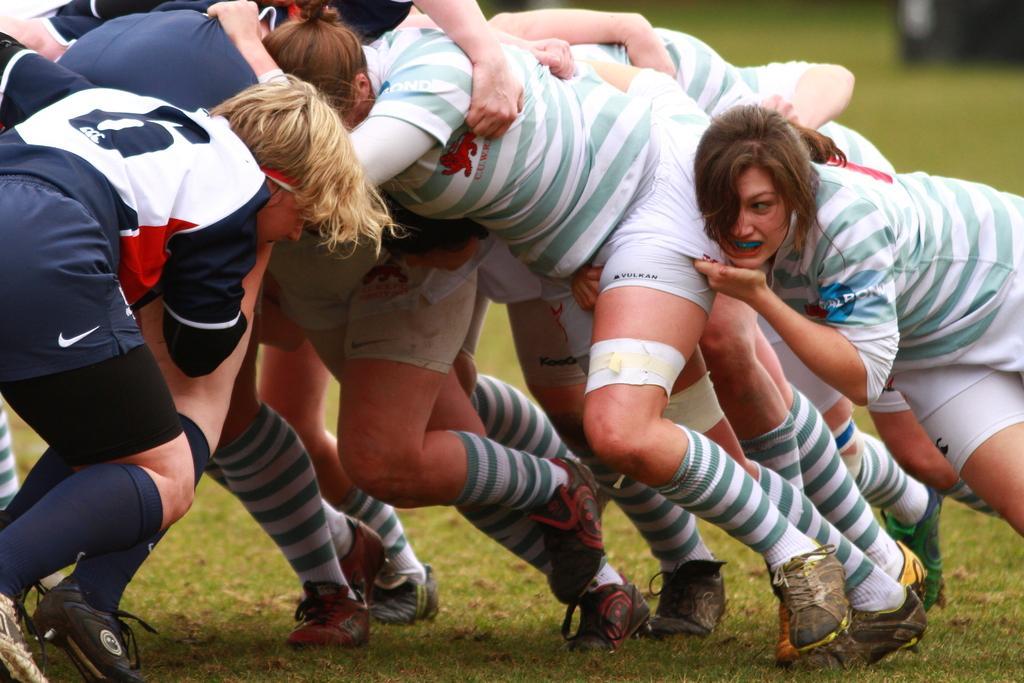In one or two sentences, can you explain what this image depicts? Here I can see few people wearing t-shirts and shorts. It seems like they are playing a game. On the ground, I can see the grass. 